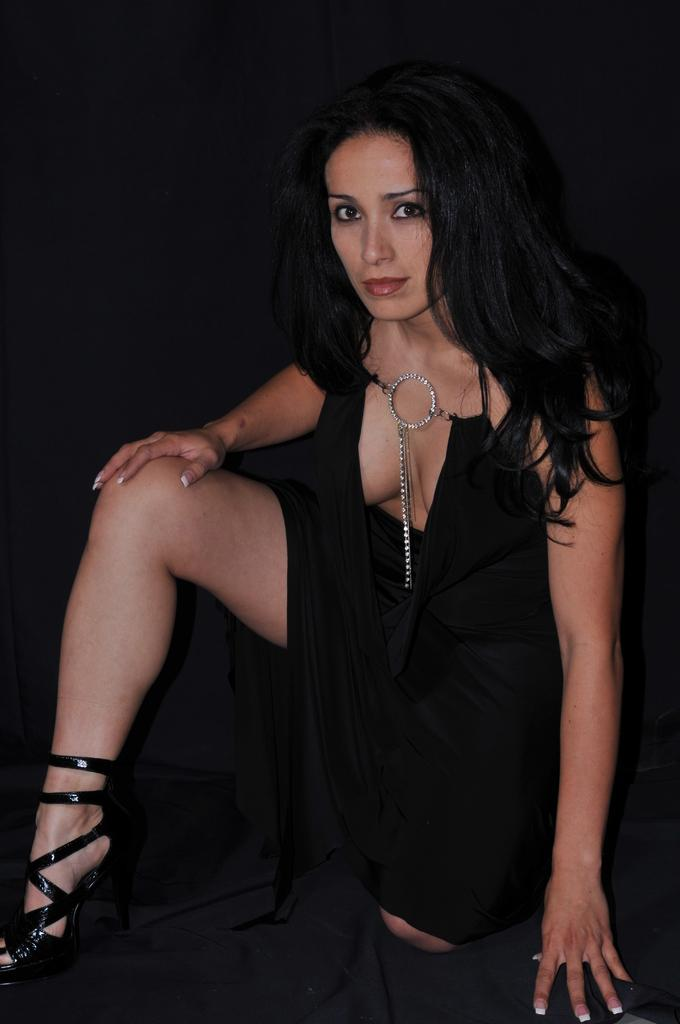Who is the main subject in the image? There is a woman in the image. What is the woman wearing? The woman is wearing a black dress. What is the color of the background in the image? The background of the image is black. What type of punishment is the woman receiving in the image? There is no indication of punishment in the image; it simply shows a woman wearing a black dress against a black background. 